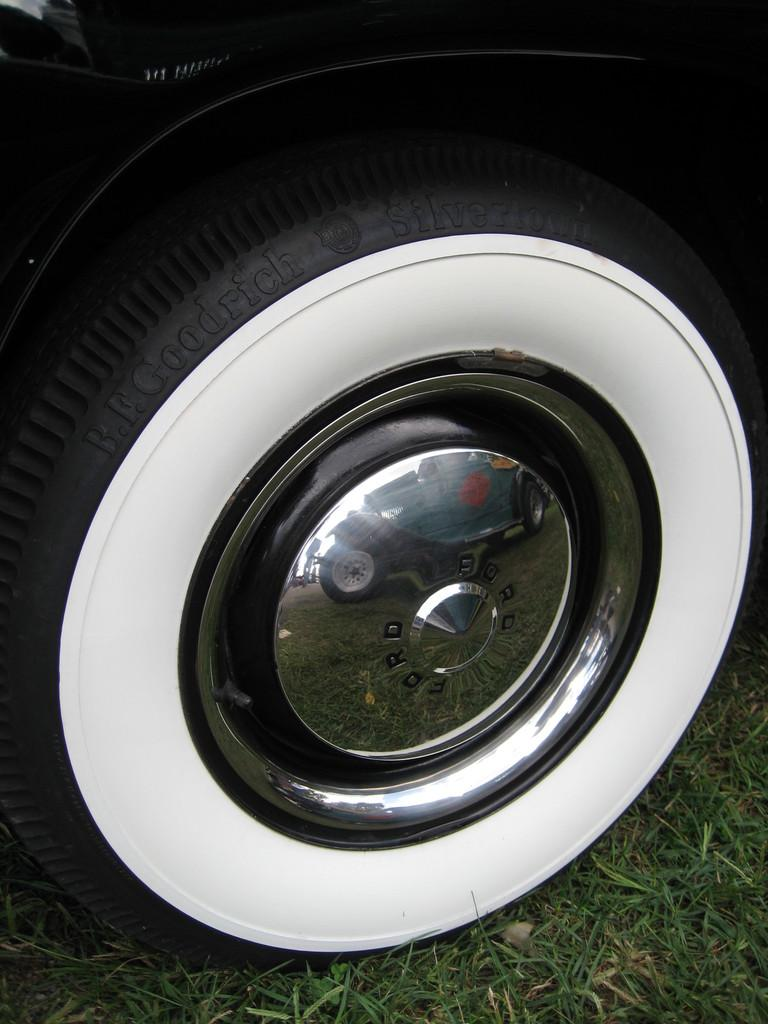What is the main subject of the image? The main subject of the image is a wheel of a motor vehicle. Can you describe the wheel in more detail? Unfortunately, the facts provided do not give any additional details about the wheel. Is there any other object or person visible in the image? No, the facts only mention the wheel of a motor vehicle. What type of shoes is the boy wearing while walking with the judge in the image? There is no boy or judge present in the image, and the only subject mentioned is the wheel of a motor vehicle. 